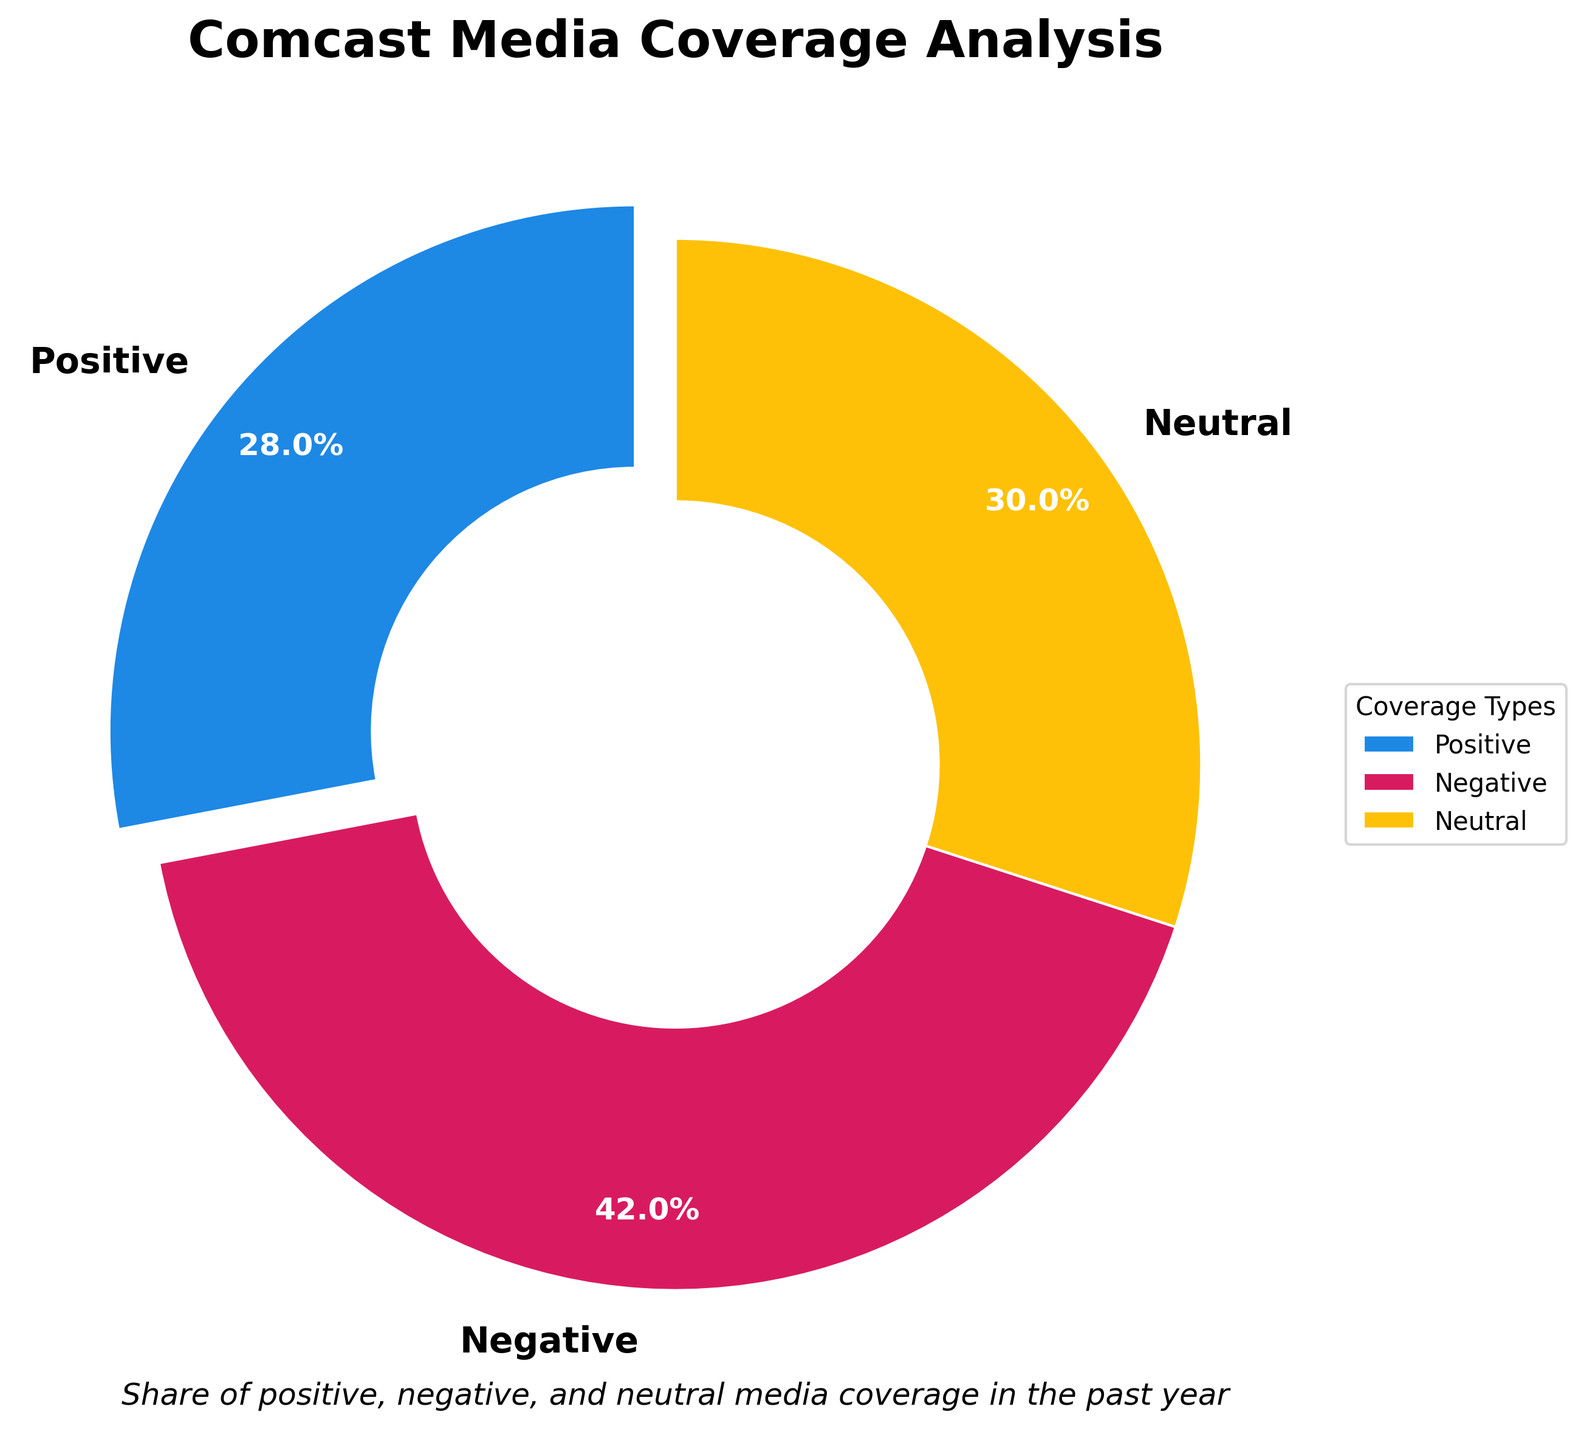Which type of media coverage has the largest share? The slice representing 'Negative' coverage is visually the largest in the pie chart, indicating it has the highest percentage.
Answer: Negative What is the combined share of positive and neutral media coverage? The percentage of 'Positive' coverage is 28%, and 'Neutral' coverage is 30%. Adding these gives 28% + 30% = 58%.
Answer: 58% How much larger is the share of negative media coverage compared to positive media coverage? The 'Negative' coverage is 42% and the 'Positive' coverage is 28%. Subtracting these percentages gives 42% - 28% = 14%.
Answer: 14% Which coverage type is closest in percentage to neutral media coverage? The 'Neutral' coverage is 30%, and the 'Positive' coverage is 28%, which is closest to 30% compared to 'Negative' coverage at 42%.
Answer: Positive What is the average share of positive and negative media coverage? The 'Positive' coverage is 28% and the 'Negative' coverage is 42%. Adding and dividing by 2 gives (28% + 42%) / 2 = 35%.
Answer: 35% In terms of color, which type of media coverage is represented by blue? The pie chart shows the color blue associated with the 'Positive' coverage segment.
Answer: Positive Which segment of the pie chart has an emphasized look (i.e., exploded/outward)? The 'Positive' coverage segment is visually separated or "exploded" from the pie chart in comparison to the other segments.
Answer: Positive Compare the size of the positive media coverage to the neutral media coverage. The 'Positive' coverage is 28% and the ‘Neutral' coverage is 30%. Therefore, the 'Neutral' share is 2% larger than the 'Positive' share.
Answer: Neutral has 2% more If we were to combine the share of positive and negative coverage, what would their total be relative to the entire coverage? The combined percentage of 'Positive' (28%) and 'Negative' (42%) is 28% + 42% = 70%, which is 70% of the entire coverage.
Answer: 70% What percentage more is the negative coverage than the neutral coverage? The 'Negative' coverage is 42%, and the 'Neutral' coverage is 30%. The difference is 42% - 30% = 12%, so the negative share is 12% more.
Answer: 12% 